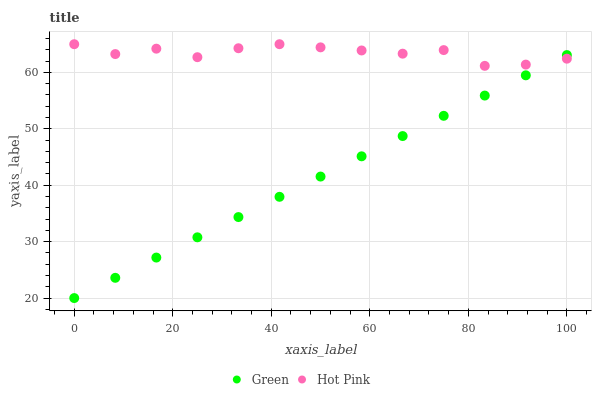Does Green have the minimum area under the curve?
Answer yes or no. Yes. Does Hot Pink have the maximum area under the curve?
Answer yes or no. Yes. Does Green have the maximum area under the curve?
Answer yes or no. No. Is Green the smoothest?
Answer yes or no. Yes. Is Hot Pink the roughest?
Answer yes or no. Yes. Is Green the roughest?
Answer yes or no. No. Does Green have the lowest value?
Answer yes or no. Yes. Does Hot Pink have the highest value?
Answer yes or no. Yes. Does Green have the highest value?
Answer yes or no. No. Does Hot Pink intersect Green?
Answer yes or no. Yes. Is Hot Pink less than Green?
Answer yes or no. No. Is Hot Pink greater than Green?
Answer yes or no. No. 